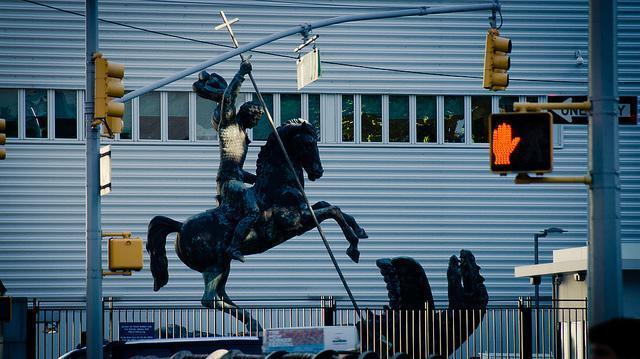How many boats are there?
Give a very brief answer. 0. 